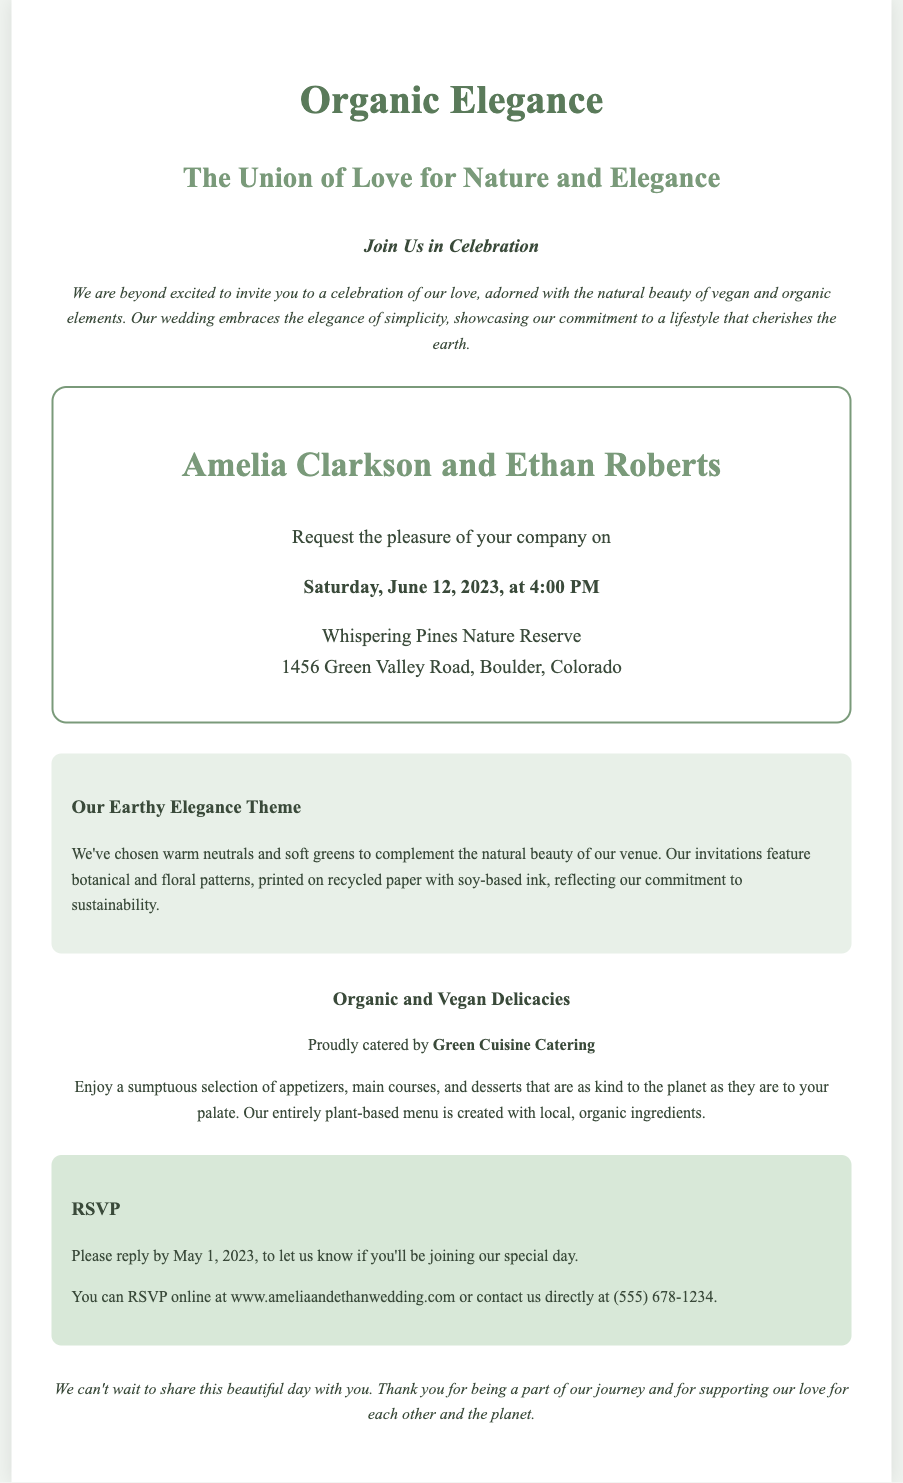What is the wedding date? The document specifies that the wedding will take place on Saturday, June 12, 2023.
Answer: June 12, 2023 Who is the groom? The wedding invitation mentions the groom's name as Ethan Roberts.
Answer: Ethan Roberts Where is the venue located? The invitation lists the venue as Whispering Pines Nature Reserve, 1456 Green Valley Road, Boulder, Colorado.
Answer: Whispering Pines Nature Reserve, 1456 Green Valley Road, Boulder, Colorado What type of catering will be provided? The invitation states that the catering will be organic and vegan, emphasizing plant-based options.
Answer: Organic and vegan What is the RSVP deadline? The document requests guests to RSVP by May 1, 2023.
Answer: May 1, 2023 What are the wedding colors mentioned? The wedding theme includes warm neutrals and soft greens, reflecting its earthy elegance.
Answer: Warm neutrals and soft greens What is the name of the caterer? The invitation proudly mentions the caterer's name as Green Cuisine Catering.
Answer: Green Cuisine Catering What kind of materials were used for the invitations? The invitation notes that it was printed on recycled paper with soy-based ink, indicating environmental consciousness.
Answer: Recycled paper with soy-based ink What is the theme of the wedding? The document describes the wedding theme as "Our Earthy Elegance Theme."
Answer: Our Earthy Elegance Theme 